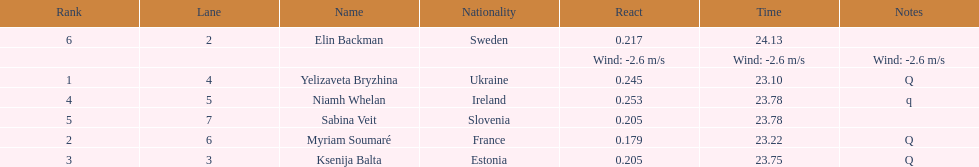Who is the first ranking player? Yelizaveta Bryzhina. 